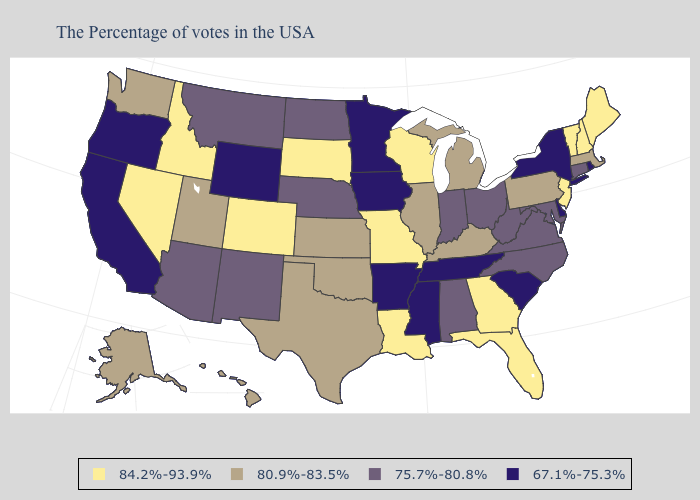What is the highest value in the South ?
Short answer required. 84.2%-93.9%. Name the states that have a value in the range 67.1%-75.3%?
Quick response, please. Rhode Island, New York, Delaware, South Carolina, Tennessee, Mississippi, Arkansas, Minnesota, Iowa, Wyoming, California, Oregon. Which states hav the highest value in the South?
Give a very brief answer. Florida, Georgia, Louisiana. Name the states that have a value in the range 84.2%-93.9%?
Give a very brief answer. Maine, New Hampshire, Vermont, New Jersey, Florida, Georgia, Wisconsin, Louisiana, Missouri, South Dakota, Colorado, Idaho, Nevada. Among the states that border New York , does New Jersey have the lowest value?
Be succinct. No. What is the lowest value in states that border New Jersey?
Be succinct. 67.1%-75.3%. What is the highest value in states that border California?
Concise answer only. 84.2%-93.9%. Name the states that have a value in the range 80.9%-83.5%?
Be succinct. Massachusetts, Pennsylvania, Michigan, Kentucky, Illinois, Kansas, Oklahoma, Texas, Utah, Washington, Alaska, Hawaii. What is the value of Delaware?
Answer briefly. 67.1%-75.3%. Which states have the lowest value in the USA?
Short answer required. Rhode Island, New York, Delaware, South Carolina, Tennessee, Mississippi, Arkansas, Minnesota, Iowa, Wyoming, California, Oregon. Which states have the highest value in the USA?
Be succinct. Maine, New Hampshire, Vermont, New Jersey, Florida, Georgia, Wisconsin, Louisiana, Missouri, South Dakota, Colorado, Idaho, Nevada. Among the states that border Oregon , which have the lowest value?
Short answer required. California. Among the states that border Virginia , which have the lowest value?
Quick response, please. Tennessee. What is the value of Massachusetts?
Answer briefly. 80.9%-83.5%. 